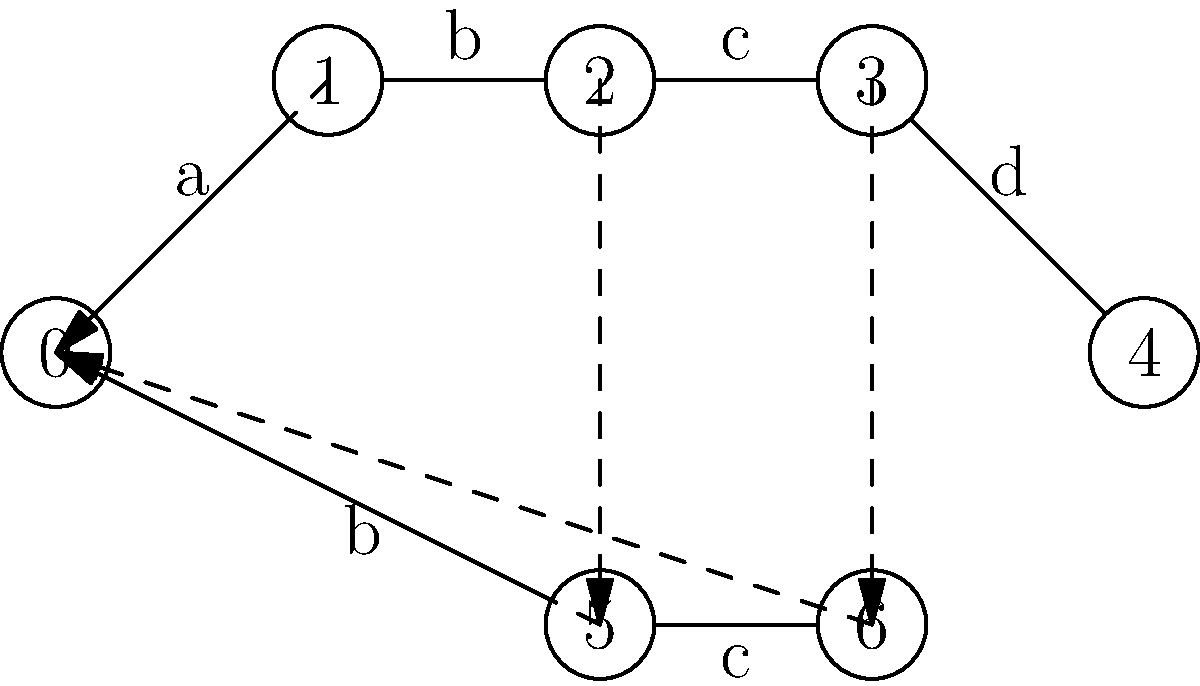Given the Aho-Corasick automaton represented as a trie structure above for the patterns "abcd" and "bc", what is the maximum number of state transitions (including both forward and failure transitions) that could occur when processing a single character in the worst-case scenario? To determine the maximum number of state transitions for a single character in the worst-case scenario, we need to analyze the Aho-Corasick automaton:

1. The automaton has 7 states (0 to 6).
2. Forward transitions (solid arrows) represent successful character matches.
3. Failure transitions (dashed arrows) are followed when a character doesn't match.

The worst-case scenario occurs when:
1. We start at the deepest state (state 4).
2. The input character doesn't match any forward transition from state 4.
3. We follow failure transitions until we find a matching transition or reach the root.

Let's trace the worst-case path:
1. Start at state 4.
2. No matching forward transition, follow failure transition to state 0.
3. At state 0, we may have a matching forward transition.

In this worst case, we make:
- 1 attempt at a forward transition from state 4 (fails)
- 1 failure transition from state 4 to state 0
- 1 potential forward transition from state 0

Therefore, the maximum number of state transitions for a single character is 3.

This process demonstrates the efficiency of the Aho-Corasick algorithm, as it ensures that even in the worst case, the number of transitions is bounded and doesn't depend on the number of patterns in the set.
Answer: 3 